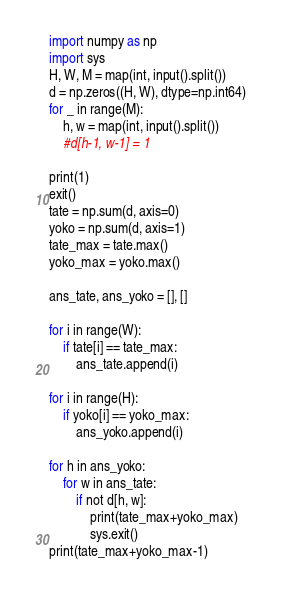<code> <loc_0><loc_0><loc_500><loc_500><_Python_>import numpy as np
import sys
H, W, M = map(int, input().split())
d = np.zeros((H, W), dtype=np.int64)
for _ in range(M):
    h, w = map(int, input().split())
    #d[h-1, w-1] = 1

print(1)
exit()
tate = np.sum(d, axis=0)
yoko = np.sum(d, axis=1)
tate_max = tate.max()
yoko_max = yoko.max()

ans_tate, ans_yoko = [], []

for i in range(W):
    if tate[i] == tate_max:
        ans_tate.append(i)

for i in range(H):
    if yoko[i] == yoko_max:
        ans_yoko.append(i)

for h in ans_yoko:
    for w in ans_tate:
        if not d[h, w]:
            print(tate_max+yoko_max)
            sys.exit()
print(tate_max+yoko_max-1)</code> 